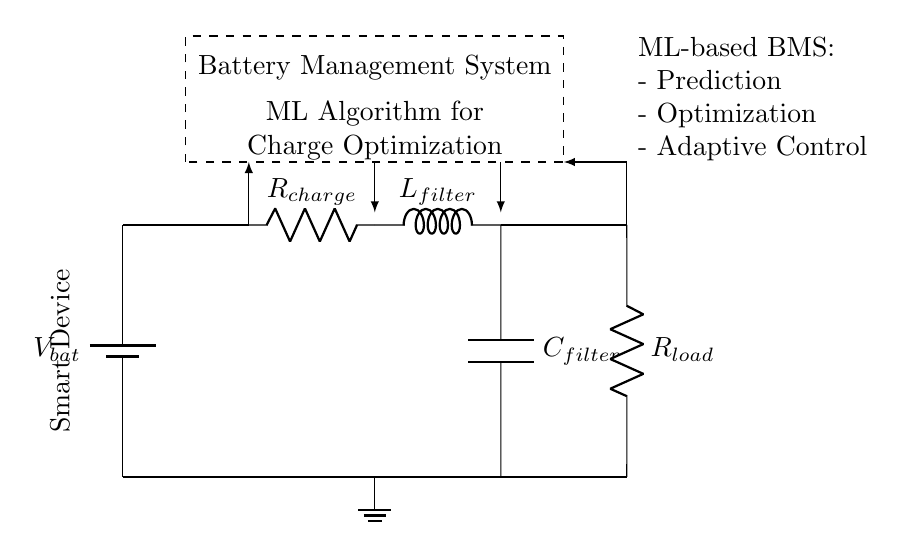What is the function of the component labeled \( R_{charge} \)? The component labeled \( R_{charge} \) is a resistor that regulates the current flowing into the battery during the charging process. It limits the charge current to prevent damage to the battery.
Answer: Resistor What role does the \( L_{filter} \) play in the circuit? The \( L_{filter} \) component is an inductor used to smooth out the current by filtering out high-frequency noise in the circuit. This helps to ensure a stable charging current to the battery.
Answer: Smoothing What is the overall purpose of the Battery Management System? The Battery Management System optimizes battery charging, monitors the battery health, and ensures safety throughout the charging process by controlling the charge and discharge cycles.
Answer: Optimization What type of control signals are used in this circuit? The control signals in this circuit are feedback signals from the battery and load that inform the Battery Management System about the current state and help adjust charging parameters accordingly.
Answer: Feedback signals How does the circuit provide feedback to the management system? Feedback is provided through sensors connected to both the charging resistor and the load, allowing the management system to monitor voltage and current conditions dynamically. This feedback loop is essential for proper charge optimization.
Answer: Through sensors What is the purpose of the capacitor \( C_{filter} \) in the circuit? The capacitor \( C_{filter} \) is utilized to smooth the output voltage by storing and releasing charge, thus reducing voltage ripple and providing a more stable voltage for the load.
Answer: Smoothing voltage How is the load represented in this circuit? The load in this circuit is represented by the component labeled \( R_{load} \), which signifies the resistance that consumes power from the battery. It helps to illustrate how the battery supplies energy to the connected device.
Answer: Resistor 